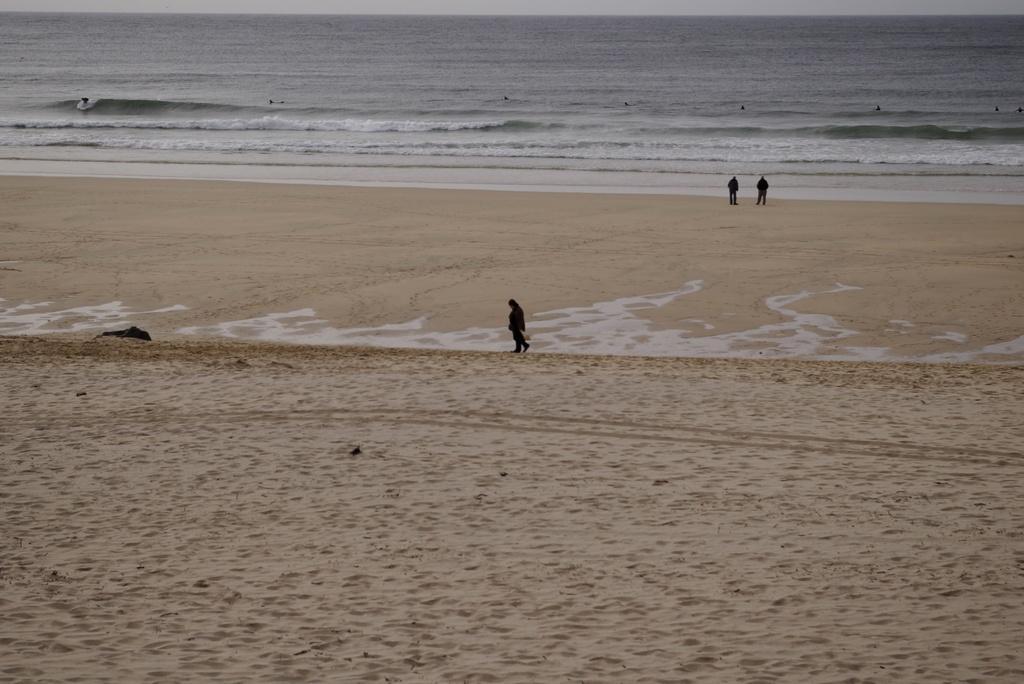How would you summarize this image in a sentence or two? In this image I can see a black colour thing over here, sand, water and here I can see few people are standing. 